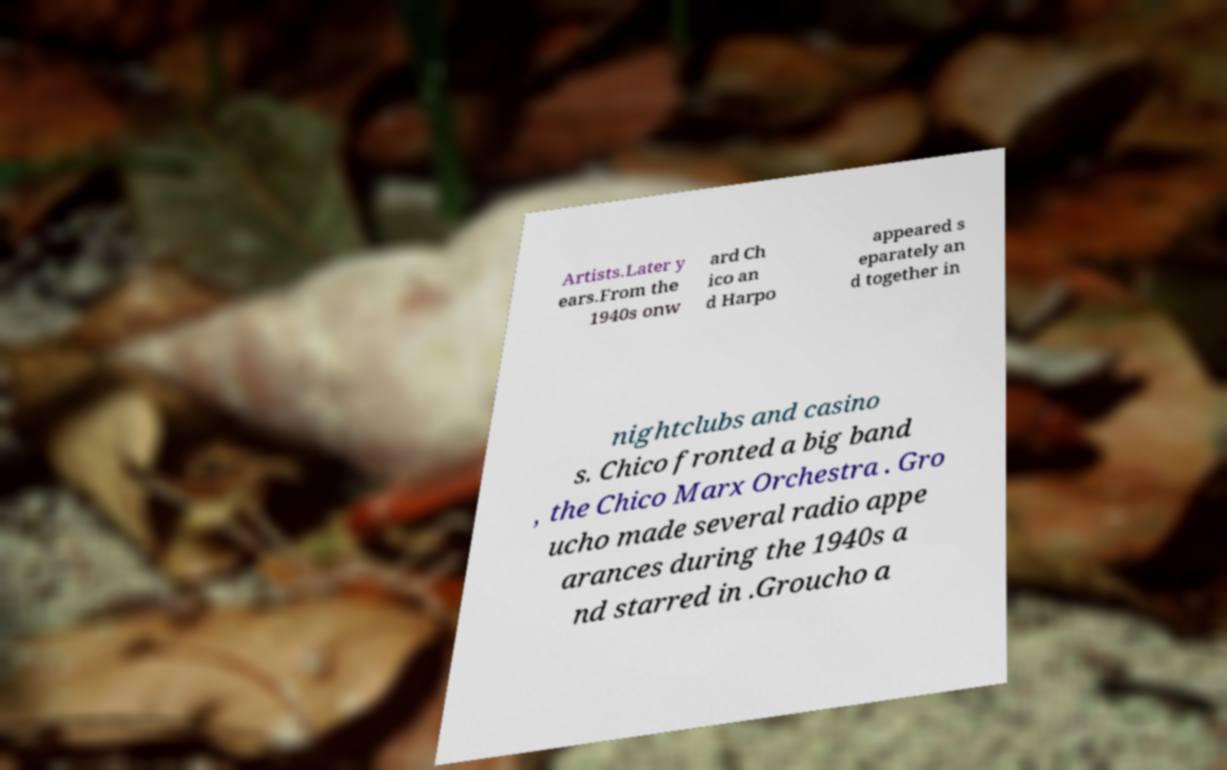What can you infer about the careers of Chico and Harpo from the information in the image? Based on the information visible in the image, Chico and Harpo had versatile entertainment careers that continued beyond the 1940s. They adapted to different performance formats, such as nightclubs and casinos, suggesting they were quite popular and had enduring appeal. Did they also act in films or was their career primarily in live performances? Yes, both Chico and Harpo are renowned for their work in film, especially as part of a famous comedy group. Their film careers were significant, though the text in the image specifically highlights their live performances in later years. 